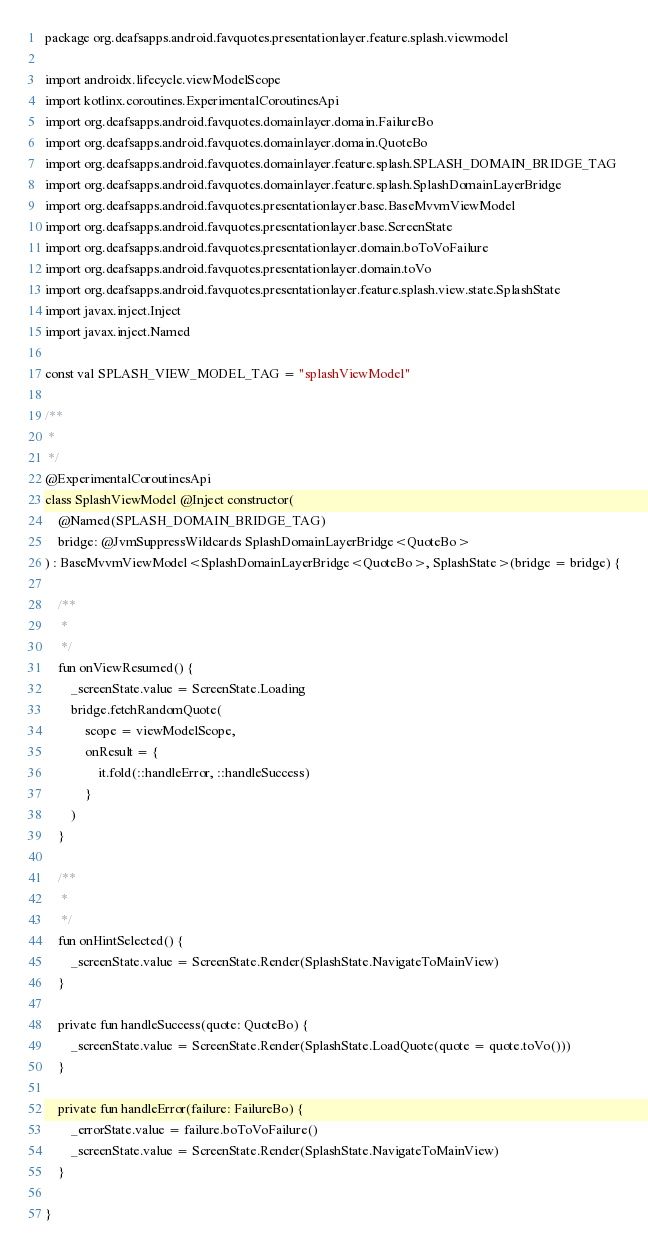<code> <loc_0><loc_0><loc_500><loc_500><_Kotlin_>package org.deafsapps.android.favquotes.presentationlayer.feature.splash.viewmodel

import androidx.lifecycle.viewModelScope
import kotlinx.coroutines.ExperimentalCoroutinesApi
import org.deafsapps.android.favquotes.domainlayer.domain.FailureBo
import org.deafsapps.android.favquotes.domainlayer.domain.QuoteBo
import org.deafsapps.android.favquotes.domainlayer.feature.splash.SPLASH_DOMAIN_BRIDGE_TAG
import org.deafsapps.android.favquotes.domainlayer.feature.splash.SplashDomainLayerBridge
import org.deafsapps.android.favquotes.presentationlayer.base.BaseMvvmViewModel
import org.deafsapps.android.favquotes.presentationlayer.base.ScreenState
import org.deafsapps.android.favquotes.presentationlayer.domain.boToVoFailure
import org.deafsapps.android.favquotes.presentationlayer.domain.toVo
import org.deafsapps.android.favquotes.presentationlayer.feature.splash.view.state.SplashState
import javax.inject.Inject
import javax.inject.Named

const val SPLASH_VIEW_MODEL_TAG = "splashViewModel"

/**
 *
 */
@ExperimentalCoroutinesApi
class SplashViewModel @Inject constructor(
    @Named(SPLASH_DOMAIN_BRIDGE_TAG)
    bridge: @JvmSuppressWildcards SplashDomainLayerBridge<QuoteBo>
) : BaseMvvmViewModel<SplashDomainLayerBridge<QuoteBo>, SplashState>(bridge = bridge) {

    /**
     *
     */
    fun onViewResumed() {
        _screenState.value = ScreenState.Loading
        bridge.fetchRandomQuote(
            scope = viewModelScope,
            onResult = {
                it.fold(::handleError, ::handleSuccess)
            }
        )
    }

    /**
     *
     */
    fun onHintSelected() {
        _screenState.value = ScreenState.Render(SplashState.NavigateToMainView)
    }

    private fun handleSuccess(quote: QuoteBo) {
        _screenState.value = ScreenState.Render(SplashState.LoadQuote(quote = quote.toVo()))
    }

    private fun handleError(failure: FailureBo) {
        _errorState.value = failure.boToVoFailure()
        _screenState.value = ScreenState.Render(SplashState.NavigateToMainView)
    }

}
</code> 